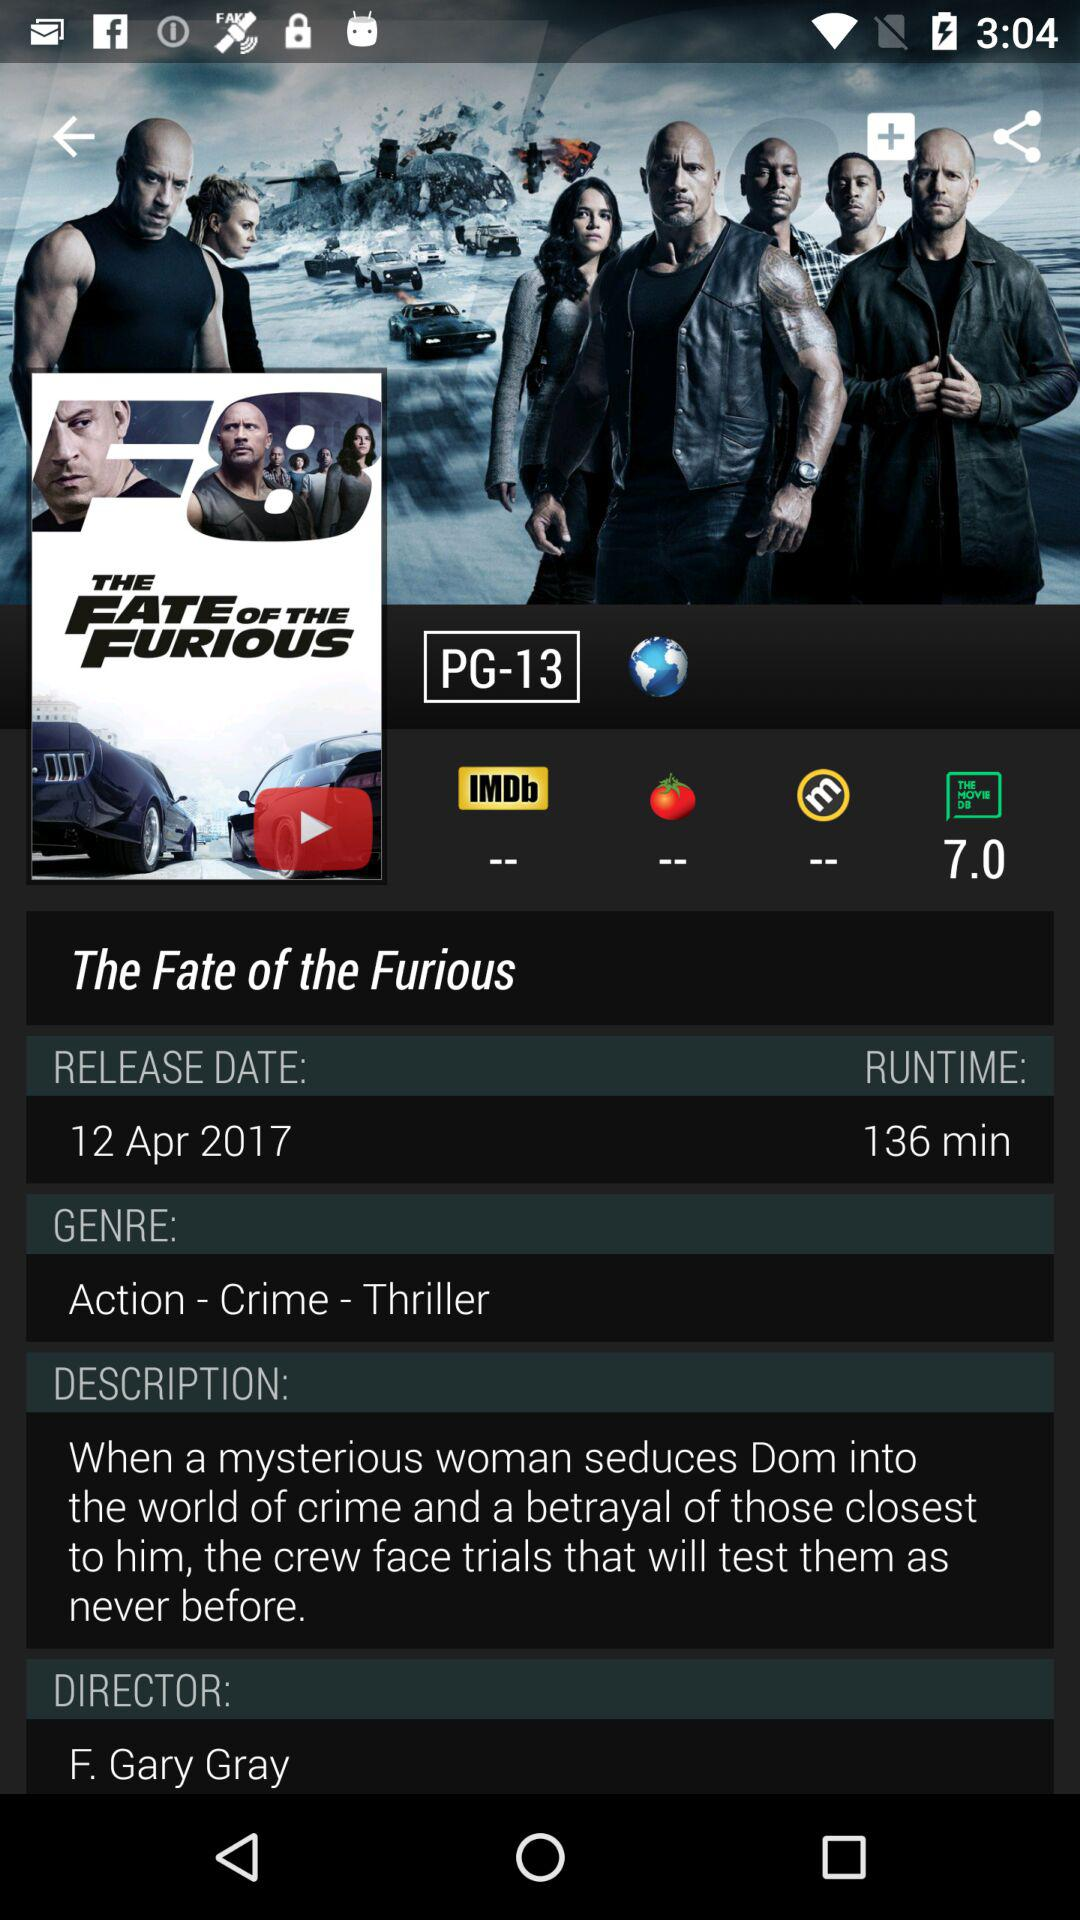When was the movie released? The movie was released on April 12, 2017. 